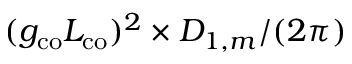<formula> <loc_0><loc_0><loc_500><loc_500>( g _ { c o } L _ { c o } ) ^ { 2 } \times D _ { 1 , m } / ( 2 \pi )</formula> 